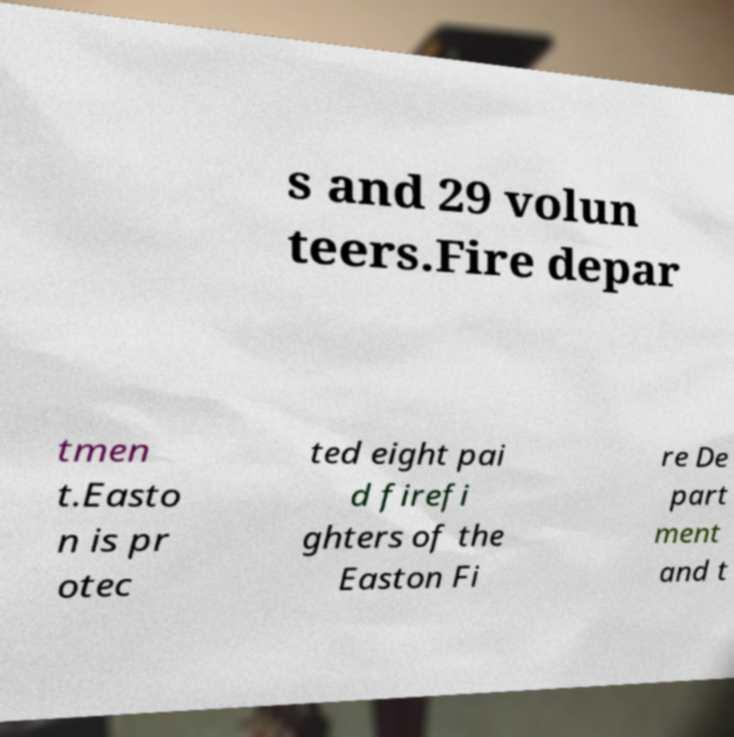Can you read and provide the text displayed in the image?This photo seems to have some interesting text. Can you extract and type it out for me? s and 29 volun teers.Fire depar tmen t.Easto n is pr otec ted eight pai d firefi ghters of the Easton Fi re De part ment and t 